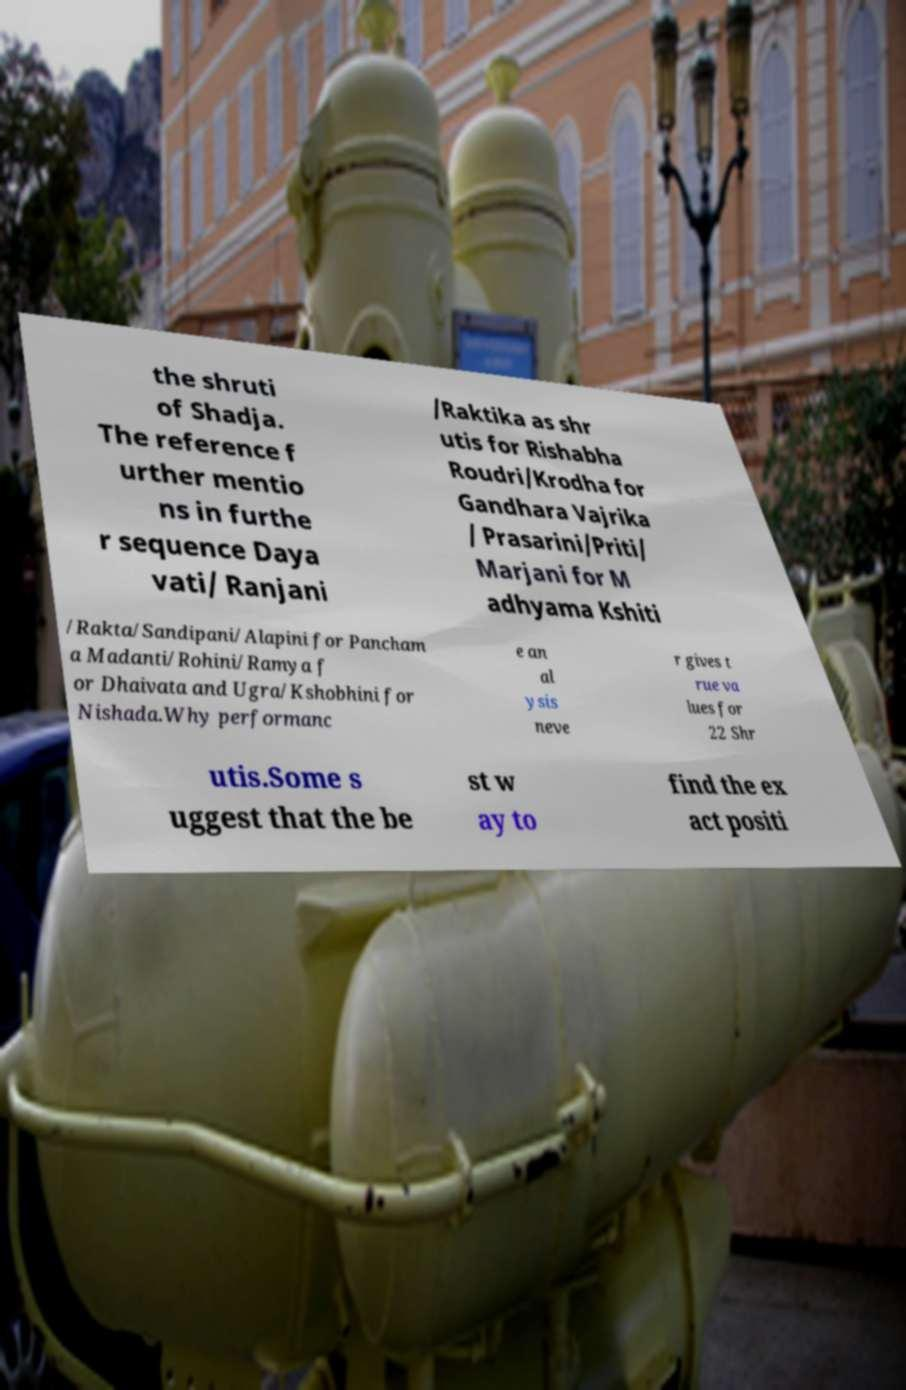Could you assist in decoding the text presented in this image and type it out clearly? the shruti of Shadja. The reference f urther mentio ns in furthe r sequence Daya vati/ Ranjani /Raktika as shr utis for Rishabha Roudri/Krodha for Gandhara Vajrika / Prasarini/Priti/ Marjani for M adhyama Kshiti /Rakta/Sandipani/Alapini for Pancham a Madanti/Rohini/Ramya f or Dhaivata and Ugra/Kshobhini for Nishada.Why performanc e an al ysis neve r gives t rue va lues for 22 Shr utis.Some s uggest that the be st w ay to find the ex act positi 